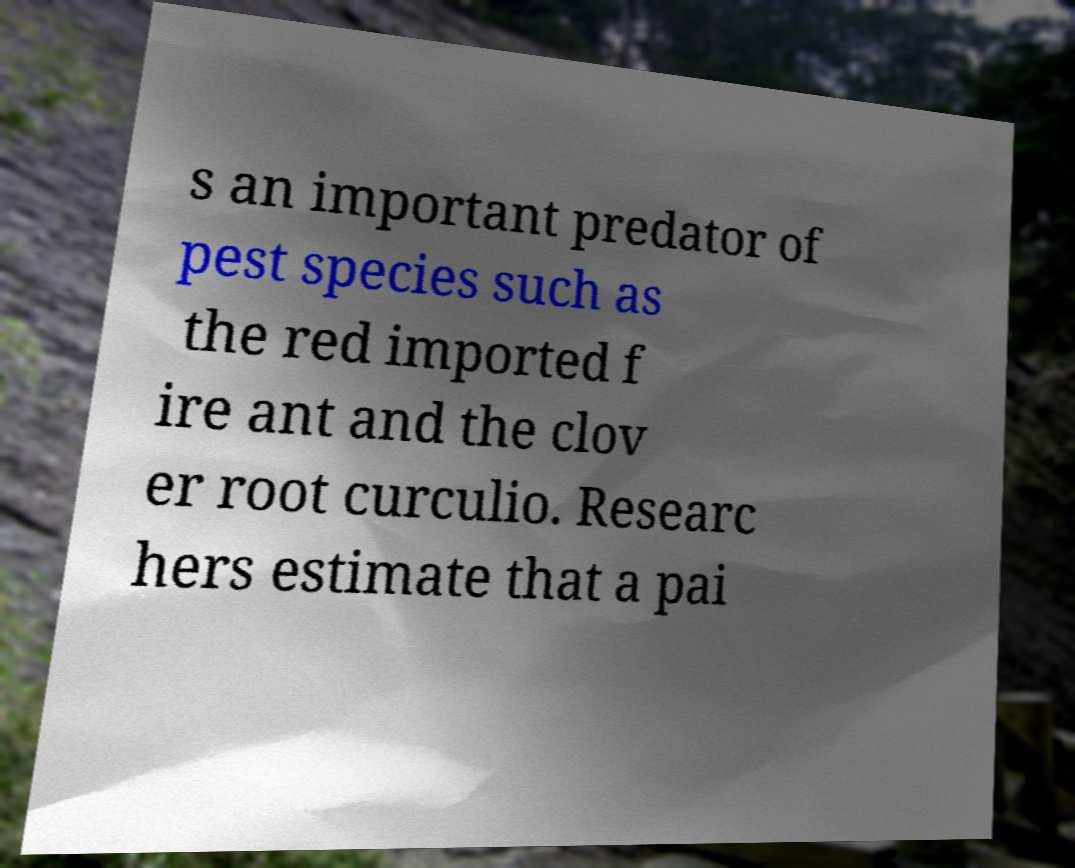What messages or text are displayed in this image? I need them in a readable, typed format. s an important predator of pest species such as the red imported f ire ant and the clov er root curculio. Researc hers estimate that a pai 